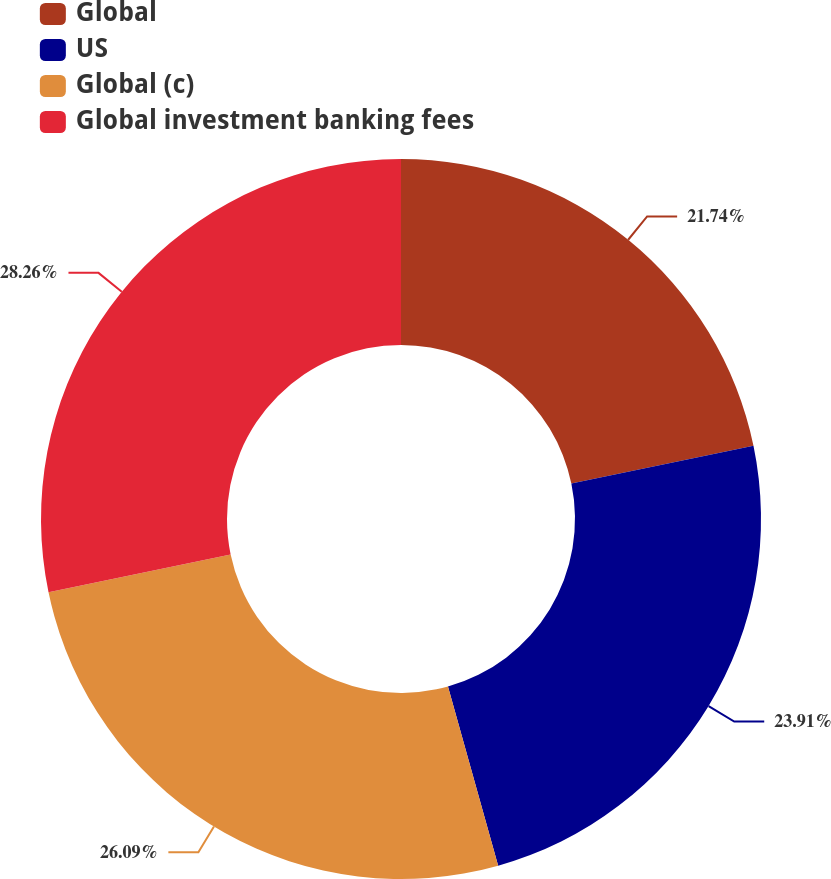<chart> <loc_0><loc_0><loc_500><loc_500><pie_chart><fcel>Global<fcel>US<fcel>Global (c)<fcel>Global investment banking fees<nl><fcel>21.74%<fcel>23.91%<fcel>26.09%<fcel>28.26%<nl></chart> 